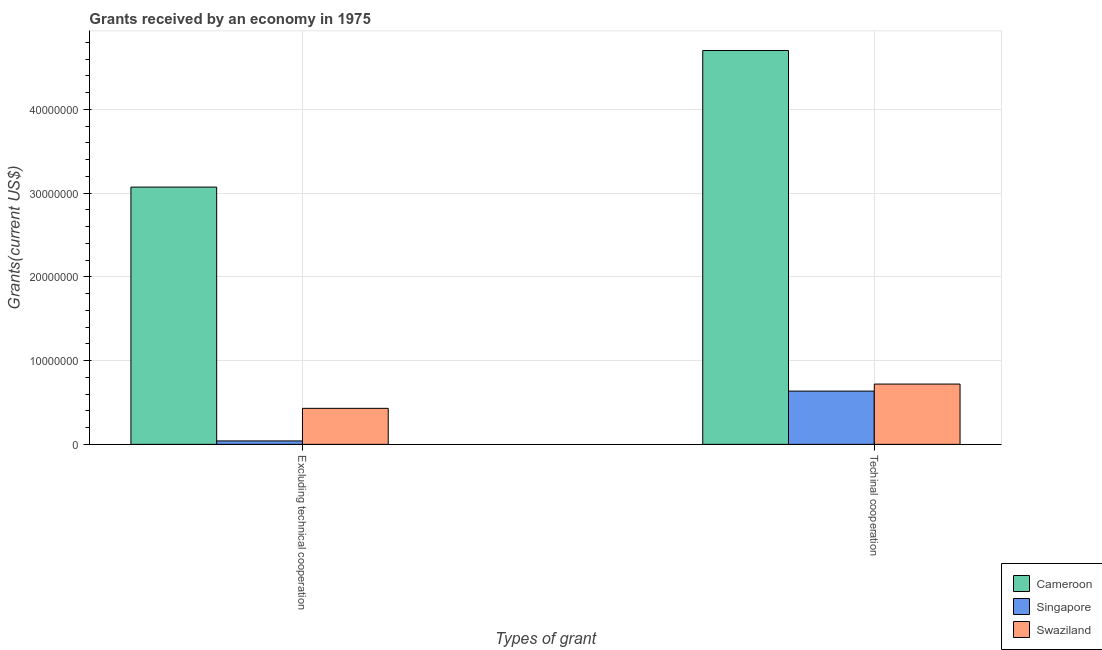How many groups of bars are there?
Give a very brief answer. 2. How many bars are there on the 2nd tick from the left?
Ensure brevity in your answer.  3. What is the label of the 1st group of bars from the left?
Offer a terse response. Excluding technical cooperation. What is the amount of grants received(including technical cooperation) in Singapore?
Offer a terse response. 6.36e+06. Across all countries, what is the maximum amount of grants received(excluding technical cooperation)?
Ensure brevity in your answer.  3.07e+07. Across all countries, what is the minimum amount of grants received(including technical cooperation)?
Ensure brevity in your answer.  6.36e+06. In which country was the amount of grants received(including technical cooperation) maximum?
Give a very brief answer. Cameroon. In which country was the amount of grants received(including technical cooperation) minimum?
Give a very brief answer. Singapore. What is the total amount of grants received(excluding technical cooperation) in the graph?
Ensure brevity in your answer.  3.54e+07. What is the difference between the amount of grants received(excluding technical cooperation) in Cameroon and that in Singapore?
Give a very brief answer. 3.03e+07. What is the difference between the amount of grants received(excluding technical cooperation) in Swaziland and the amount of grants received(including technical cooperation) in Singapore?
Offer a very short reply. -2.06e+06. What is the average amount of grants received(excluding technical cooperation) per country?
Offer a very short reply. 1.18e+07. What is the difference between the amount of grants received(excluding technical cooperation) and amount of grants received(including technical cooperation) in Singapore?
Offer a very short reply. -5.95e+06. What is the ratio of the amount of grants received(excluding technical cooperation) in Singapore to that in Cameroon?
Keep it short and to the point. 0.01. Is the amount of grants received(excluding technical cooperation) in Cameroon less than that in Swaziland?
Your response must be concise. No. What does the 3rd bar from the left in Excluding technical cooperation represents?
Offer a terse response. Swaziland. What does the 2nd bar from the right in Excluding technical cooperation represents?
Make the answer very short. Singapore. How many countries are there in the graph?
Give a very brief answer. 3. What is the difference between two consecutive major ticks on the Y-axis?
Your answer should be compact. 1.00e+07. Are the values on the major ticks of Y-axis written in scientific E-notation?
Your answer should be very brief. No. Does the graph contain any zero values?
Make the answer very short. No. Where does the legend appear in the graph?
Your response must be concise. Bottom right. How many legend labels are there?
Make the answer very short. 3. What is the title of the graph?
Provide a short and direct response. Grants received by an economy in 1975. Does "Switzerland" appear as one of the legend labels in the graph?
Your answer should be very brief. No. What is the label or title of the X-axis?
Provide a succinct answer. Types of grant. What is the label or title of the Y-axis?
Your answer should be compact. Grants(current US$). What is the Grants(current US$) of Cameroon in Excluding technical cooperation?
Offer a terse response. 3.07e+07. What is the Grants(current US$) in Singapore in Excluding technical cooperation?
Your answer should be compact. 4.10e+05. What is the Grants(current US$) of Swaziland in Excluding technical cooperation?
Provide a short and direct response. 4.30e+06. What is the Grants(current US$) of Cameroon in Techinal cooperation?
Your response must be concise. 4.70e+07. What is the Grants(current US$) in Singapore in Techinal cooperation?
Your response must be concise. 6.36e+06. What is the Grants(current US$) in Swaziland in Techinal cooperation?
Provide a short and direct response. 7.20e+06. Across all Types of grant, what is the maximum Grants(current US$) of Cameroon?
Ensure brevity in your answer.  4.70e+07. Across all Types of grant, what is the maximum Grants(current US$) in Singapore?
Your answer should be very brief. 6.36e+06. Across all Types of grant, what is the maximum Grants(current US$) in Swaziland?
Your response must be concise. 7.20e+06. Across all Types of grant, what is the minimum Grants(current US$) in Cameroon?
Provide a short and direct response. 3.07e+07. Across all Types of grant, what is the minimum Grants(current US$) in Singapore?
Your response must be concise. 4.10e+05. Across all Types of grant, what is the minimum Grants(current US$) of Swaziland?
Your response must be concise. 4.30e+06. What is the total Grants(current US$) of Cameroon in the graph?
Provide a short and direct response. 7.78e+07. What is the total Grants(current US$) in Singapore in the graph?
Provide a succinct answer. 6.77e+06. What is the total Grants(current US$) in Swaziland in the graph?
Keep it short and to the point. 1.15e+07. What is the difference between the Grants(current US$) of Cameroon in Excluding technical cooperation and that in Techinal cooperation?
Ensure brevity in your answer.  -1.63e+07. What is the difference between the Grants(current US$) in Singapore in Excluding technical cooperation and that in Techinal cooperation?
Offer a very short reply. -5.95e+06. What is the difference between the Grants(current US$) of Swaziland in Excluding technical cooperation and that in Techinal cooperation?
Give a very brief answer. -2.90e+06. What is the difference between the Grants(current US$) of Cameroon in Excluding technical cooperation and the Grants(current US$) of Singapore in Techinal cooperation?
Make the answer very short. 2.44e+07. What is the difference between the Grants(current US$) in Cameroon in Excluding technical cooperation and the Grants(current US$) in Swaziland in Techinal cooperation?
Offer a terse response. 2.35e+07. What is the difference between the Grants(current US$) of Singapore in Excluding technical cooperation and the Grants(current US$) of Swaziland in Techinal cooperation?
Your answer should be compact. -6.79e+06. What is the average Grants(current US$) of Cameroon per Types of grant?
Provide a short and direct response. 3.89e+07. What is the average Grants(current US$) of Singapore per Types of grant?
Your response must be concise. 3.38e+06. What is the average Grants(current US$) of Swaziland per Types of grant?
Your answer should be compact. 5.75e+06. What is the difference between the Grants(current US$) in Cameroon and Grants(current US$) in Singapore in Excluding technical cooperation?
Provide a short and direct response. 3.03e+07. What is the difference between the Grants(current US$) in Cameroon and Grants(current US$) in Swaziland in Excluding technical cooperation?
Provide a short and direct response. 2.64e+07. What is the difference between the Grants(current US$) in Singapore and Grants(current US$) in Swaziland in Excluding technical cooperation?
Keep it short and to the point. -3.89e+06. What is the difference between the Grants(current US$) of Cameroon and Grants(current US$) of Singapore in Techinal cooperation?
Your answer should be compact. 4.07e+07. What is the difference between the Grants(current US$) of Cameroon and Grants(current US$) of Swaziland in Techinal cooperation?
Provide a short and direct response. 3.98e+07. What is the difference between the Grants(current US$) in Singapore and Grants(current US$) in Swaziland in Techinal cooperation?
Offer a terse response. -8.40e+05. What is the ratio of the Grants(current US$) in Cameroon in Excluding technical cooperation to that in Techinal cooperation?
Keep it short and to the point. 0.65. What is the ratio of the Grants(current US$) of Singapore in Excluding technical cooperation to that in Techinal cooperation?
Your answer should be compact. 0.06. What is the ratio of the Grants(current US$) in Swaziland in Excluding technical cooperation to that in Techinal cooperation?
Provide a short and direct response. 0.6. What is the difference between the highest and the second highest Grants(current US$) in Cameroon?
Offer a very short reply. 1.63e+07. What is the difference between the highest and the second highest Grants(current US$) in Singapore?
Your response must be concise. 5.95e+06. What is the difference between the highest and the second highest Grants(current US$) of Swaziland?
Keep it short and to the point. 2.90e+06. What is the difference between the highest and the lowest Grants(current US$) in Cameroon?
Your answer should be very brief. 1.63e+07. What is the difference between the highest and the lowest Grants(current US$) in Singapore?
Provide a succinct answer. 5.95e+06. What is the difference between the highest and the lowest Grants(current US$) of Swaziland?
Offer a terse response. 2.90e+06. 